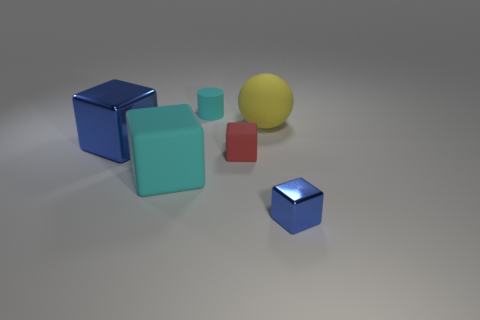How do the objects in the image differ in color? The objects in the image present a variety of colors: two cubes are blue with different shades, a large aqua cube, a yellow sphere, and a small red cube. Together, they create a visually stimulating contrast of colors. 